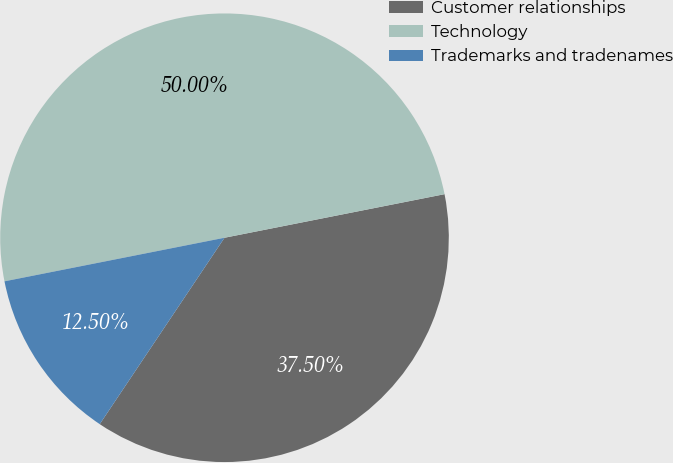Convert chart. <chart><loc_0><loc_0><loc_500><loc_500><pie_chart><fcel>Customer relationships<fcel>Technology<fcel>Trademarks and tradenames<nl><fcel>37.5%<fcel>50.0%<fcel>12.5%<nl></chart> 